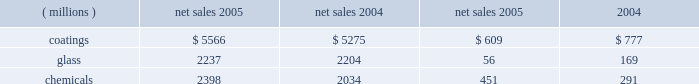Management 2019s discussion and analysis action antitrust legal settlement .
Net income for 2005 and 2004 included an aftertax charge of $ 13 million , or 8 cents a share , and $ 19 million , or 11 cents a share , respectively , to reflect the net increase in the current value of the company 2019s obligation under the ppg settlement arrangement relating to asbestos claims .
Results of business segments net sales operating income ( millions ) 2005 2004 2005 2004 .
Coatings sales increased $ 291 million or 5% ( 5 % ) in 2005 .
Sales increased 3% ( 3 % ) due to higher selling prices across all businesses except automotive ; 1% ( 1 % ) due to improved volumes as increases in our aerospace , architectural and original equipment automotive businesses offset volume declines in automotive refinish and industrial coatings ; and 1% ( 1 % ) due to the positive effects of foreign currency translation .
Operating income decreased $ 168 million in 2005 .
The adverse impact of inflation totaled $ 315 million , of which $ 245 million was attributable to higher raw material costs .
Higher year-over-year selling prices increased operating earnings by $ 169 million .
Coatings operating earnings were reduced by the $ 132 million charge for the cost of the marvin legal settlement net of insurance recoveries .
Other factors increasing coatings operating income in 2005 were the increased sales volumes described above , manufacturing efficiencies , formula cost reductions and higher other income .
Glass sales increased $ 33 million or 1% ( 1 % ) in 2005 .
Sales increased 1% ( 1 % ) due to improved volumes as increases in our automotive replacement glass , insurance and services and performance glazings ( flat glass ) businesses offset volume declines in our fiber glass and automotive original equipment glass businesses .
The positive effects of foreign currency translation were largely offset by lower selling prices primarily in our automotive replacement glass and automotive original equipment businesses .
Operating income decreased $ 113 million in 2005 .
The federal glass class action antitrust legal settlement of $ 61 million , the $ 49 million impact of rising natural gas costs and the absence of the $ 19 million gain in 2004 from the sale/ leaseback of precious metal combined to account for a reduction in operating earnings of $ 129 million .
The remaining year-over-year increase in glass operating earnings of $ 16 million resulted primarily from improved manufacturing efficiencies and lower overhead costs exceeding the adverse impact of other inflation .
Our continuing efforts in 2005 to position the fiber glass business for future growth in profitability were adversely impacted by the rise in fourth quarter natural gas prices , slightly lower year-over-year sales , lower equity earnings due to weaker pricing in the asian electronics market , and the absence of the $ 19 million gain which occurred in 2004 stemming from the sale/ leaseback of precious metals .
Despite high energy costs , we expect fiber glass earnings to improve in 2006 because of price strengthening in the asian electronics market , which began to occur in the fourth quarter of 2005 , increased cost reduction initiatives and the positive impact resulting from the start up of our new joint venture in china .
This joint venture will produce high labor content fiber glass reinforcement products and take advantage of lower labor costs , allowing us to refocus our u.s .
Production capacity on higher margin direct process products .
The 2005 operating earnings of our north american automotive oem glass business declined by $ 30 million compared with 2004 .
Significant structural changes continue to occur in the north american automotive industry , including the loss of u.s .
Market share by general motors and ford .
This has created a very challenging and competitive environment for all suppliers to the domestic oems , including our business .
About half of the decline in earnings resulted from the impact of rising natural gas costs , particularly in the fourth quarter , combined with the traditional adverse impact of year-over-year sales price reductions producing a decline in earnings that exceeded our successful efforts to reduce manufacturing costs .
The other half of the 2005 decline was due to lower sales volumes and mix and higher new program launch costs .
The challenging competitive environment and high energy prices will continue in 2006 .
Our business is working in 2006 to improve its performance through increased manufacturing efficiencies , structural cost reduction initiatives , focusing on profitable growth opportunities and improving our sales mix .
Chemicals sales increased $ 364 million or 18% ( 18 % ) in 2005 .
Sales increased 21% ( 21 % ) due to higher selling prices , primarily for chlor-alkali products , and 1% ( 1 % ) due to the combination of an acquisition in our optical products business and the positive effects of foreign currency translation .
Total volumes declined 4% ( 4 % ) as volume increases in optical products were more than offset by volume declines in chlor-alkali and fine chemicals .
Volume in chlor-alkali products and silicas were adversely impacted in the third and fourth quarters by the hurricanes .
Operating income increased $ 160 million in 2005 .
The primary factor increasing operating income was the record high selling prices in chlor-alkali .
Factors decreasing operating income were higher inflation , including $ 136 million due to increased energy and ethylene costs ; $ 34 million of direct costs related to the impact of the hurricanes ; $ 27 million due to the asset impairment charge related to our fine chemicals business ; lower sales volumes ; higher manufacturing costs and increased environmental expenses .
The increase in chemicals operating earnings occurred primarily through the first eight months of 2005 .
The hurricanes hit in september impacting volumes and costs in september through november and contributing to the rise in natural gas prices which lowered fourth quarter chemicals earnings by $ 58 million , almost 57% ( 57 % ) of the full year impact of higher natural gas prices .
The damage caused by hurricane rita resulted in the shutdown of our lake charles , la chemical plant for a total of eight days in september and an additional five 18 2005 ppg annual report and form 10-k .
What was the operating margin for the coatings segment in 2005? 
Computations: (609 / 5566)
Answer: 0.10941. 